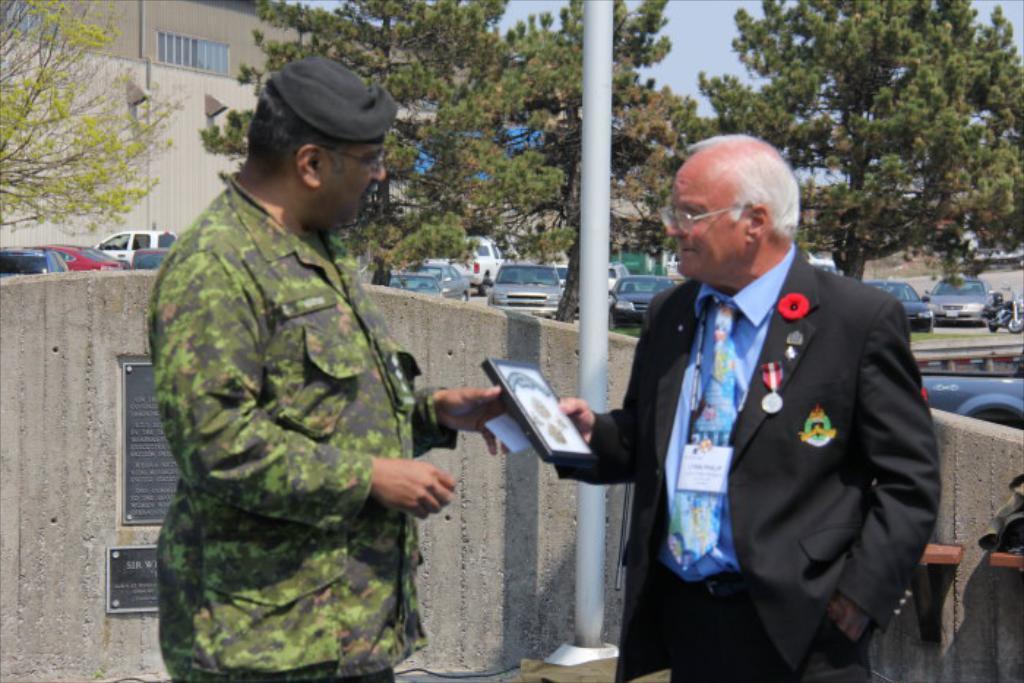How would you summarize this image in a sentence or two? In this image we can see two persons and an object. In the background of the image there is a wall, vehicles, trees, buildings, pole, the sky and other objects. 